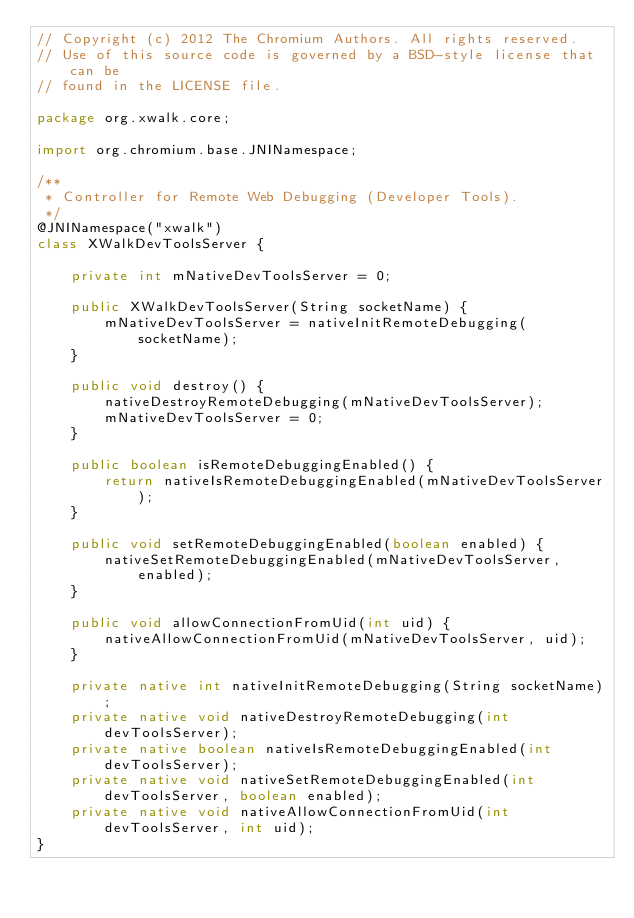<code> <loc_0><loc_0><loc_500><loc_500><_Java_>// Copyright (c) 2012 The Chromium Authors. All rights reserved.
// Use of this source code is governed by a BSD-style license that can be
// found in the LICENSE file.

package org.xwalk.core;

import org.chromium.base.JNINamespace;

/**
 * Controller for Remote Web Debugging (Developer Tools).
 */
@JNINamespace("xwalk")
class XWalkDevToolsServer {

    private int mNativeDevToolsServer = 0;

    public XWalkDevToolsServer(String socketName) {
        mNativeDevToolsServer = nativeInitRemoteDebugging(socketName);
    }

    public void destroy() {
        nativeDestroyRemoteDebugging(mNativeDevToolsServer);
        mNativeDevToolsServer = 0;
    }

    public boolean isRemoteDebuggingEnabled() {
        return nativeIsRemoteDebuggingEnabled(mNativeDevToolsServer);
    }

    public void setRemoteDebuggingEnabled(boolean enabled) {
        nativeSetRemoteDebuggingEnabled(mNativeDevToolsServer, enabled);
    }

    public void allowConnectionFromUid(int uid) {
        nativeAllowConnectionFromUid(mNativeDevToolsServer, uid);
    }

    private native int nativeInitRemoteDebugging(String socketName);
    private native void nativeDestroyRemoteDebugging(int devToolsServer);
    private native boolean nativeIsRemoteDebuggingEnabled(int devToolsServer);
    private native void nativeSetRemoteDebuggingEnabled(int devToolsServer, boolean enabled);
    private native void nativeAllowConnectionFromUid(int devToolsServer, int uid);
}
</code> 